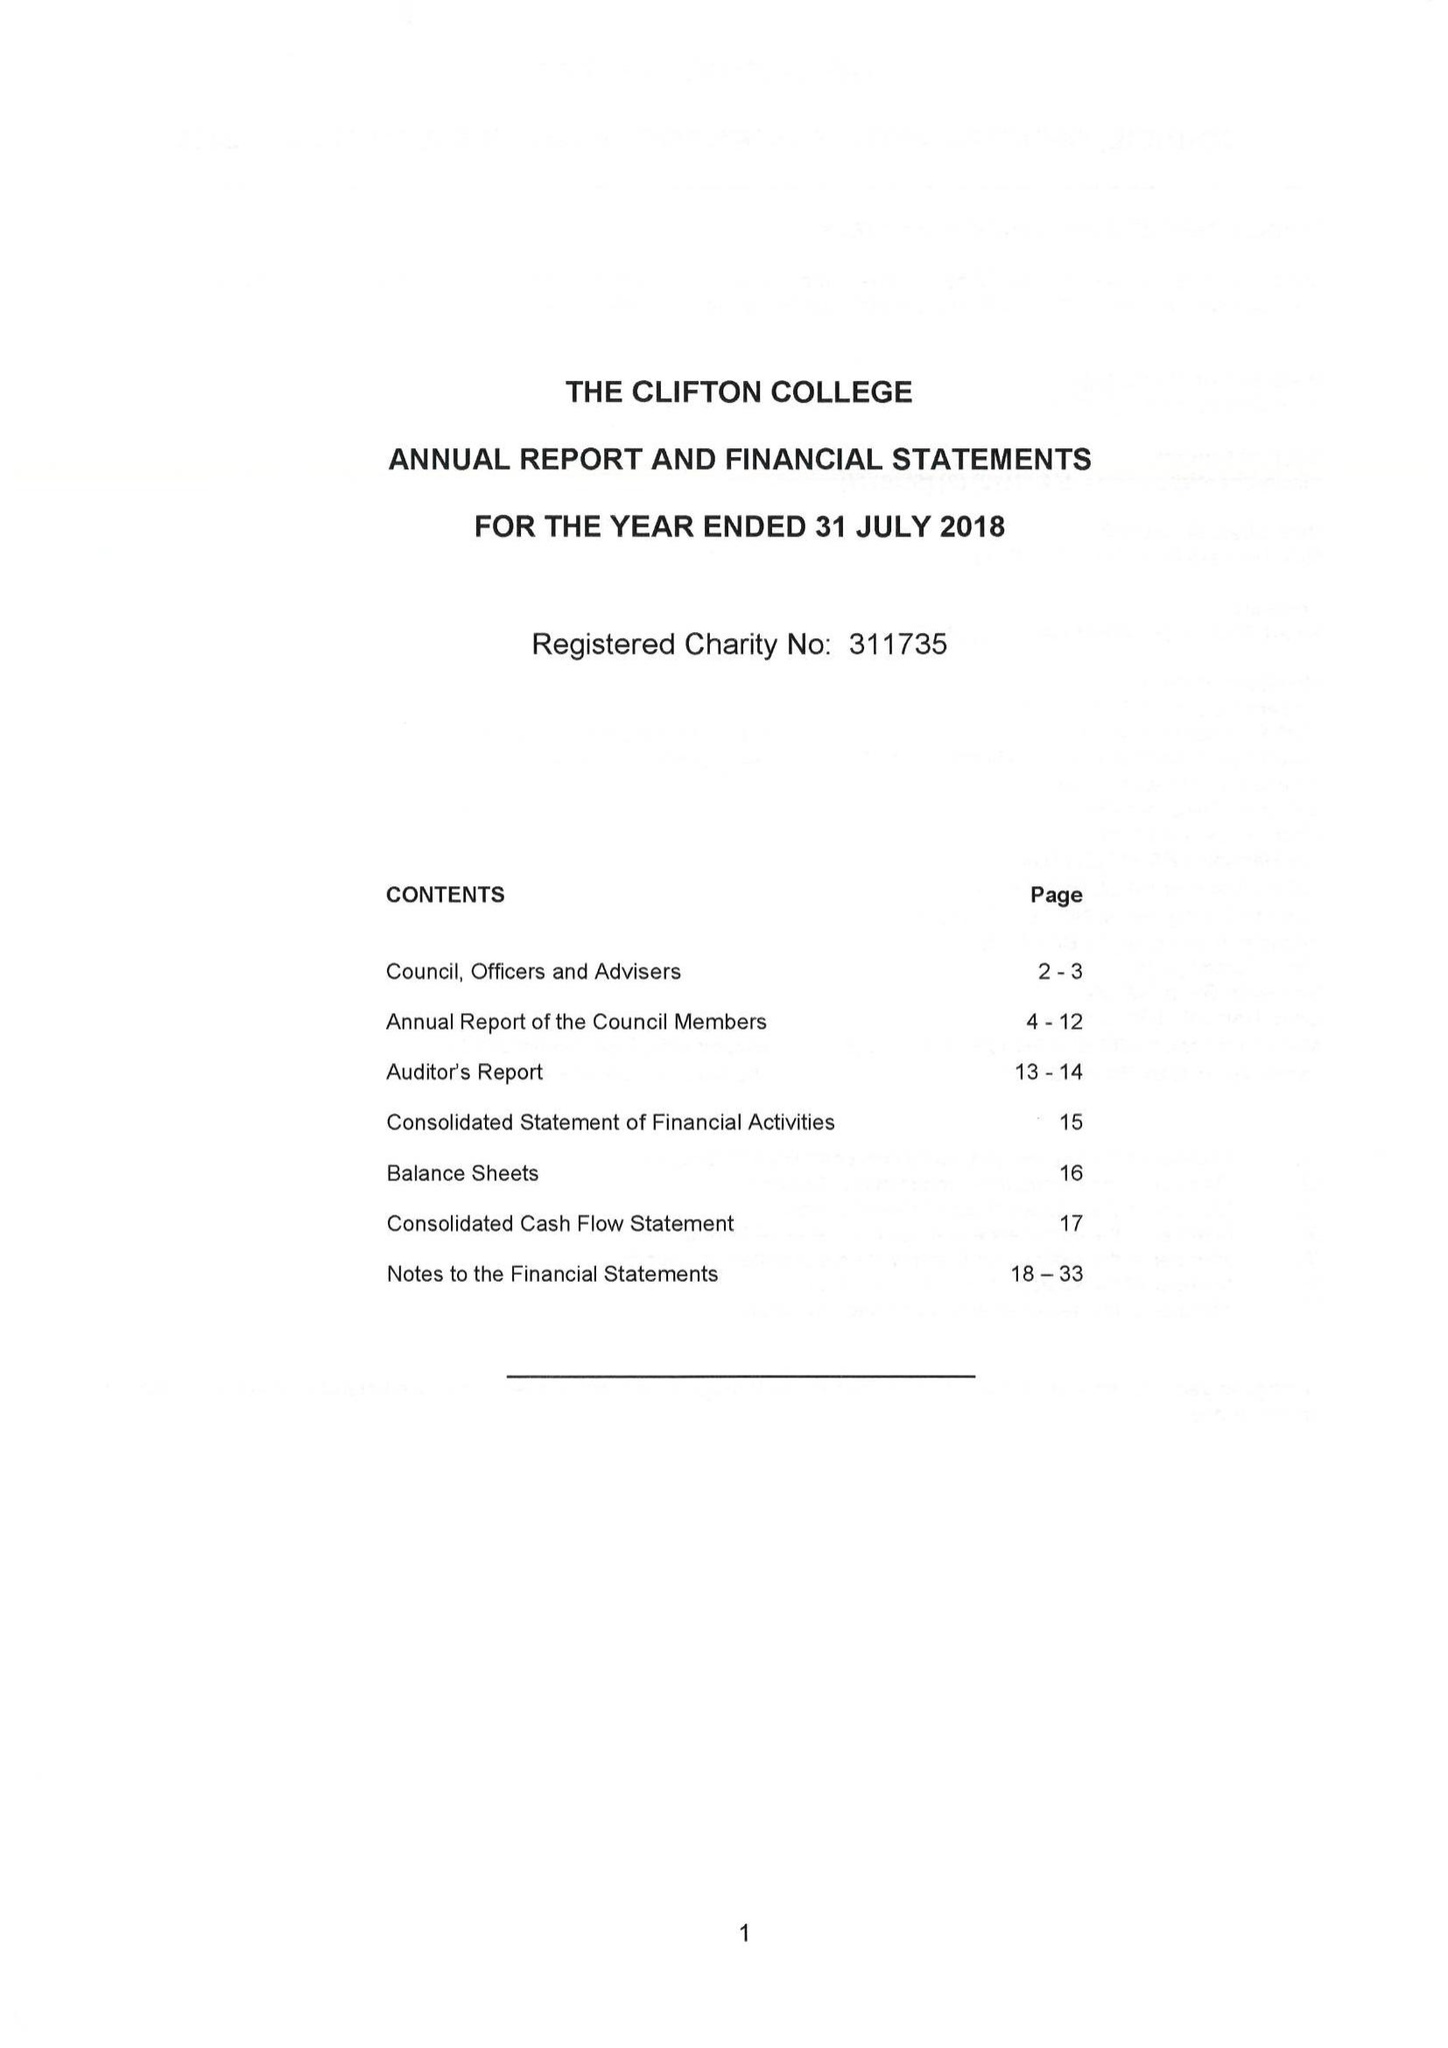What is the value for the address__post_town?
Answer the question using a single word or phrase. BRISTOL 